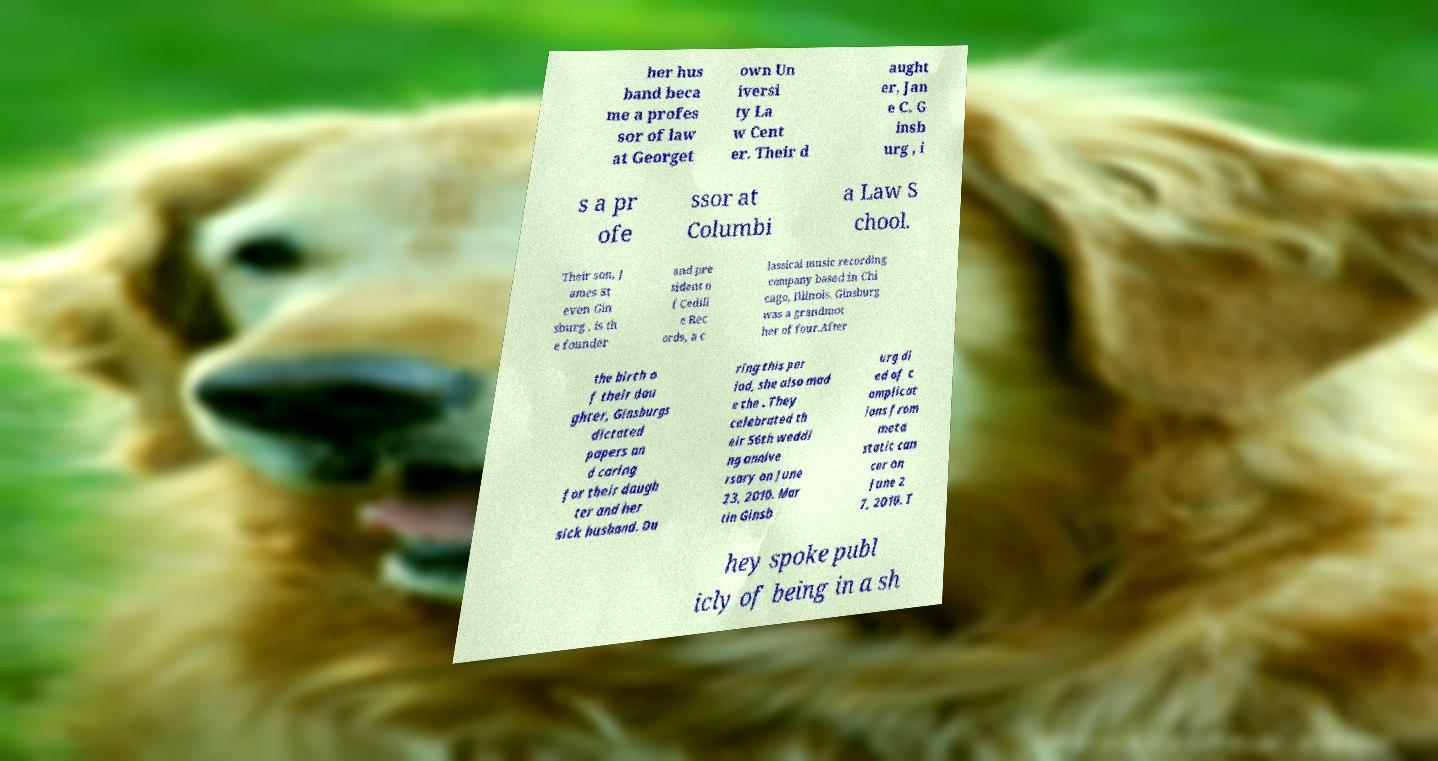Could you assist in decoding the text presented in this image and type it out clearly? her hus band beca me a profes sor of law at Georget own Un iversi ty La w Cent er. Their d aught er, Jan e C. G insb urg , i s a pr ofe ssor at Columbi a Law S chool. Their son, J ames St even Gin sburg , is th e founder and pre sident o f Cedill e Rec ords, a c lassical music recording company based in Chi cago, Illinois. Ginsburg was a grandmot her of four.After the birth o f their dau ghter, Ginsburgs dictated papers an d caring for their daugh ter and her sick husband. Du ring this per iod, she also mad e the . They celebrated th eir 56th weddi ng annive rsary on June 23, 2010. Mar tin Ginsb urg di ed of c omplicat ions from meta static can cer on June 2 7, 2010. T hey spoke publ icly of being in a sh 